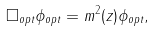Convert formula to latex. <formula><loc_0><loc_0><loc_500><loc_500>\Box _ { o p t } \phi _ { o p t } = m ^ { 2 } ( z ) \phi _ { o p t } ,</formula> 